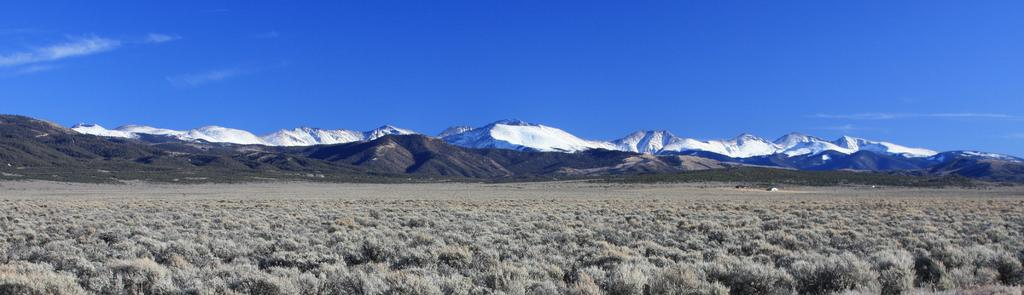What type of vegetation is present in the image? There is dried grass in the image. What geographical features can be seen in the image? There are mountains in the image. What is the condition of some parts of the mountains? Some parts of the mountains are covered with snow. Can you see a carriage being pulled by geese in the image? No, there is no carriage or geese present in the image. 